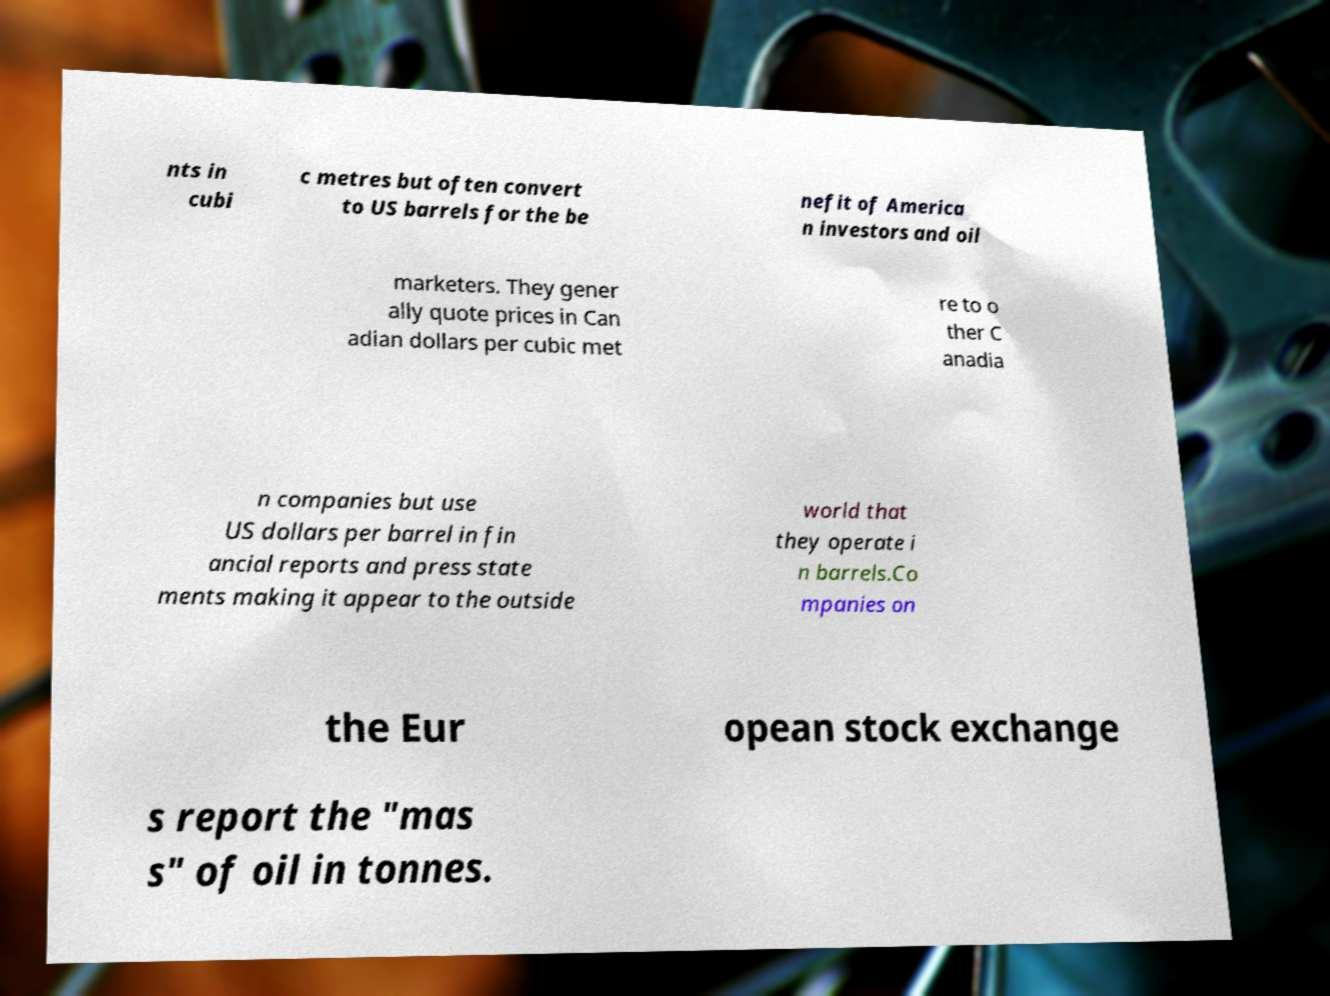Please read and relay the text visible in this image. What does it say? nts in cubi c metres but often convert to US barrels for the be nefit of America n investors and oil marketers. They gener ally quote prices in Can adian dollars per cubic met re to o ther C anadia n companies but use US dollars per barrel in fin ancial reports and press state ments making it appear to the outside world that they operate i n barrels.Co mpanies on the Eur opean stock exchange s report the "mas s" of oil in tonnes. 